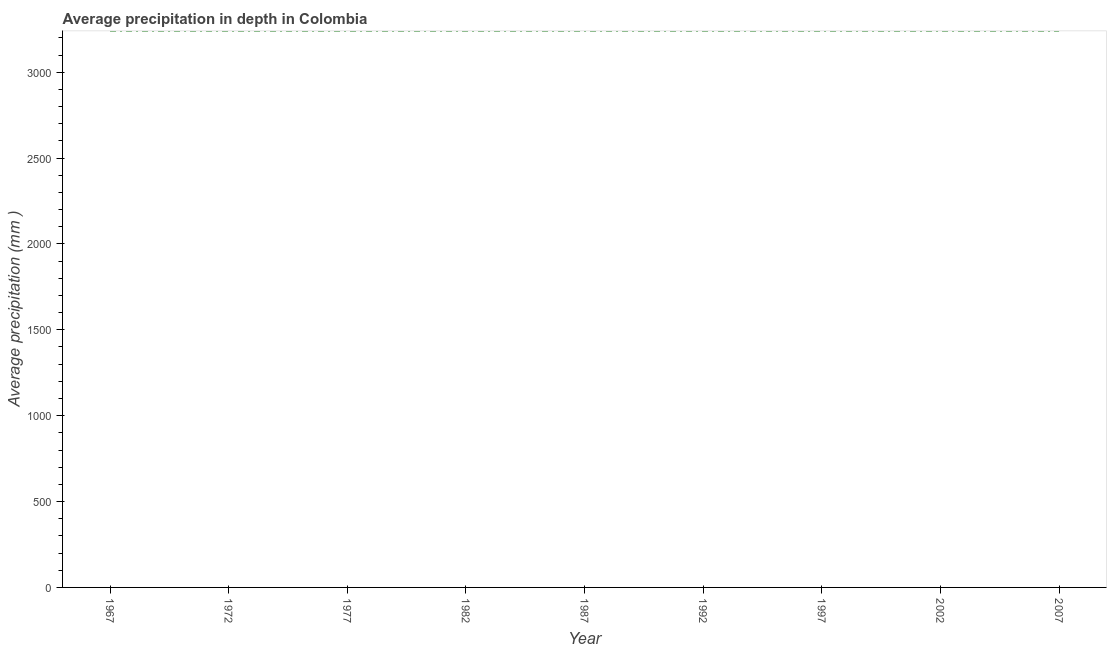What is the average precipitation in depth in 1977?
Provide a short and direct response. 3240. Across all years, what is the maximum average precipitation in depth?
Your response must be concise. 3240. Across all years, what is the minimum average precipitation in depth?
Your answer should be compact. 3240. In which year was the average precipitation in depth maximum?
Your answer should be compact. 1967. In which year was the average precipitation in depth minimum?
Keep it short and to the point. 1967. What is the sum of the average precipitation in depth?
Your answer should be compact. 2.92e+04. What is the difference between the average precipitation in depth in 1977 and 1992?
Your answer should be very brief. 0. What is the average average precipitation in depth per year?
Provide a short and direct response. 3240. What is the median average precipitation in depth?
Your answer should be compact. 3240. Do a majority of the years between 1967 and 2007 (inclusive) have average precipitation in depth greater than 700 mm?
Offer a very short reply. Yes. Is the difference between the average precipitation in depth in 1987 and 1992 greater than the difference between any two years?
Your answer should be very brief. Yes. What is the difference between the highest and the second highest average precipitation in depth?
Your answer should be compact. 0. What is the difference between the highest and the lowest average precipitation in depth?
Your answer should be compact. 0. How many lines are there?
Your response must be concise. 1. What is the difference between two consecutive major ticks on the Y-axis?
Provide a short and direct response. 500. Does the graph contain grids?
Provide a succinct answer. No. What is the title of the graph?
Keep it short and to the point. Average precipitation in depth in Colombia. What is the label or title of the Y-axis?
Ensure brevity in your answer.  Average precipitation (mm ). What is the Average precipitation (mm ) of 1967?
Provide a short and direct response. 3240. What is the Average precipitation (mm ) of 1972?
Your answer should be very brief. 3240. What is the Average precipitation (mm ) in 1977?
Provide a succinct answer. 3240. What is the Average precipitation (mm ) in 1982?
Provide a succinct answer. 3240. What is the Average precipitation (mm ) of 1987?
Provide a succinct answer. 3240. What is the Average precipitation (mm ) of 1992?
Give a very brief answer. 3240. What is the Average precipitation (mm ) of 1997?
Keep it short and to the point. 3240. What is the Average precipitation (mm ) of 2002?
Make the answer very short. 3240. What is the Average precipitation (mm ) in 2007?
Offer a very short reply. 3240. What is the difference between the Average precipitation (mm ) in 1967 and 1977?
Give a very brief answer. 0. What is the difference between the Average precipitation (mm ) in 1967 and 1997?
Make the answer very short. 0. What is the difference between the Average precipitation (mm ) in 1967 and 2002?
Your answer should be very brief. 0. What is the difference between the Average precipitation (mm ) in 1967 and 2007?
Offer a terse response. 0. What is the difference between the Average precipitation (mm ) in 1972 and 1977?
Give a very brief answer. 0. What is the difference between the Average precipitation (mm ) in 1972 and 1982?
Give a very brief answer. 0. What is the difference between the Average precipitation (mm ) in 1972 and 1997?
Offer a terse response. 0. What is the difference between the Average precipitation (mm ) in 1972 and 2002?
Provide a succinct answer. 0. What is the difference between the Average precipitation (mm ) in 1977 and 1987?
Make the answer very short. 0. What is the difference between the Average precipitation (mm ) in 1982 and 1997?
Give a very brief answer. 0. What is the difference between the Average precipitation (mm ) in 1982 and 2002?
Make the answer very short. 0. What is the difference between the Average precipitation (mm ) in 1987 and 1992?
Make the answer very short. 0. What is the difference between the Average precipitation (mm ) in 1987 and 1997?
Provide a succinct answer. 0. What is the difference between the Average precipitation (mm ) in 1987 and 2002?
Provide a succinct answer. 0. What is the difference between the Average precipitation (mm ) in 1992 and 1997?
Your answer should be compact. 0. What is the difference between the Average precipitation (mm ) in 1992 and 2002?
Keep it short and to the point. 0. What is the difference between the Average precipitation (mm ) in 1997 and 2002?
Your response must be concise. 0. What is the difference between the Average precipitation (mm ) in 1997 and 2007?
Your answer should be compact. 0. What is the difference between the Average precipitation (mm ) in 2002 and 2007?
Give a very brief answer. 0. What is the ratio of the Average precipitation (mm ) in 1967 to that in 1977?
Your answer should be compact. 1. What is the ratio of the Average precipitation (mm ) in 1967 to that in 1982?
Your answer should be very brief. 1. What is the ratio of the Average precipitation (mm ) in 1967 to that in 1987?
Offer a very short reply. 1. What is the ratio of the Average precipitation (mm ) in 1972 to that in 1977?
Offer a terse response. 1. What is the ratio of the Average precipitation (mm ) in 1972 to that in 1992?
Offer a terse response. 1. What is the ratio of the Average precipitation (mm ) in 1972 to that in 1997?
Keep it short and to the point. 1. What is the ratio of the Average precipitation (mm ) in 1972 to that in 2002?
Provide a succinct answer. 1. What is the ratio of the Average precipitation (mm ) in 1977 to that in 1987?
Offer a terse response. 1. What is the ratio of the Average precipitation (mm ) in 1977 to that in 1992?
Offer a terse response. 1. What is the ratio of the Average precipitation (mm ) in 1977 to that in 1997?
Ensure brevity in your answer.  1. What is the ratio of the Average precipitation (mm ) in 1977 to that in 2007?
Provide a succinct answer. 1. What is the ratio of the Average precipitation (mm ) in 1982 to that in 1987?
Offer a very short reply. 1. What is the ratio of the Average precipitation (mm ) in 1982 to that in 1997?
Your response must be concise. 1. What is the ratio of the Average precipitation (mm ) in 1982 to that in 2002?
Provide a short and direct response. 1. What is the ratio of the Average precipitation (mm ) in 1992 to that in 2007?
Keep it short and to the point. 1. What is the ratio of the Average precipitation (mm ) in 1997 to that in 2002?
Your answer should be compact. 1. What is the ratio of the Average precipitation (mm ) in 1997 to that in 2007?
Your response must be concise. 1. 